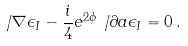Convert formula to latex. <formula><loc_0><loc_0><loc_500><loc_500>\not \, \nabla \epsilon _ { I } - { \frac { i } { 4 } e ^ { 2 \phi } \not \, \partial a \epsilon _ { I } } = 0 \, .</formula> 